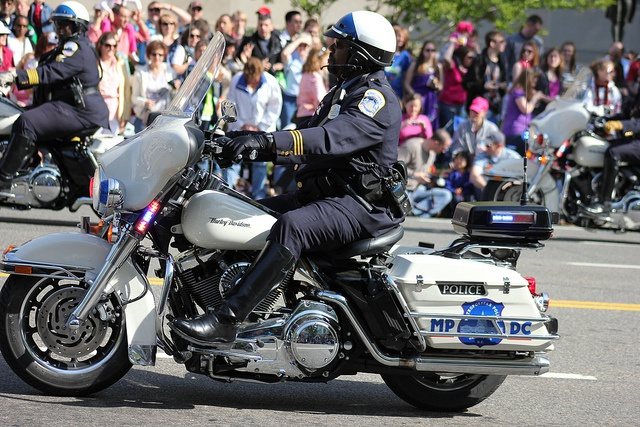Describe the objects in this image and their specific colors. I can see motorcycle in black, darkgray, gray, and white tones, people in black, white, gray, and darkgray tones, people in black, gray, and white tones, people in black, gray, and white tones, and motorcycle in black, darkgray, gray, and lightgray tones in this image. 